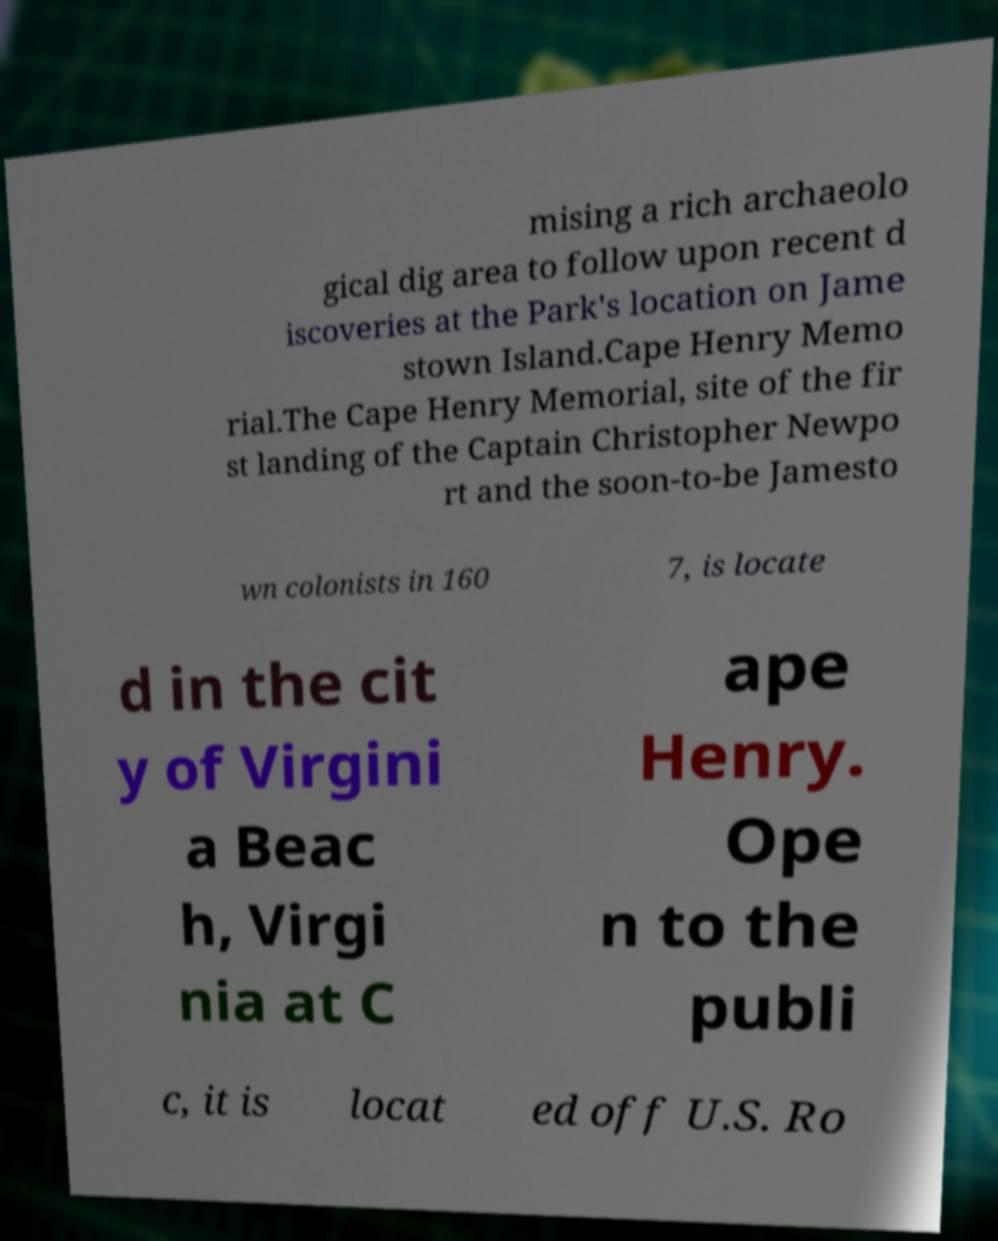Please identify and transcribe the text found in this image. mising a rich archaeolo gical dig area to follow upon recent d iscoveries at the Park's location on Jame stown Island.Cape Henry Memo rial.The Cape Henry Memorial, site of the fir st landing of the Captain Christopher Newpo rt and the soon-to-be Jamesto wn colonists in 160 7, is locate d in the cit y of Virgini a Beac h, Virgi nia at C ape Henry. Ope n to the publi c, it is locat ed off U.S. Ro 